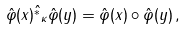Convert formula to latex. <formula><loc_0><loc_0><loc_500><loc_500>\hat { \varphi } ( x ) \hat { ^ { * } } _ { \kappa } \hat { \varphi } ( y ) = \hat { \varphi } ( x ) \circ \hat { \varphi } ( y ) \, ,</formula> 